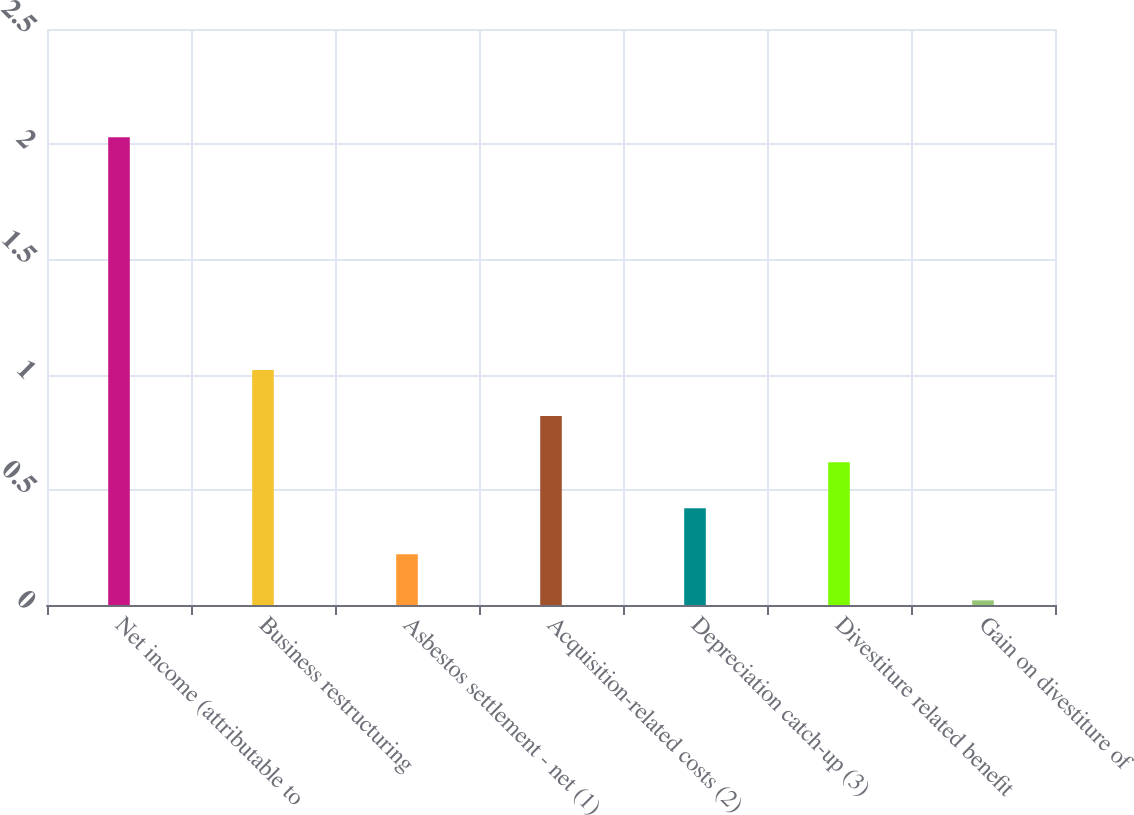<chart> <loc_0><loc_0><loc_500><loc_500><bar_chart><fcel>Net income (attributable to<fcel>Business restructuring<fcel>Asbestos settlement - net (1)<fcel>Acquisition-related costs (2)<fcel>Depreciation catch-up (3)<fcel>Divestiture related benefit<fcel>Gain on divestiture of<nl><fcel>2.03<fcel>1.02<fcel>0.22<fcel>0.82<fcel>0.42<fcel>0.62<fcel>0.02<nl></chart> 